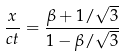Convert formula to latex. <formula><loc_0><loc_0><loc_500><loc_500>\frac { x } { c t } = \frac { \beta + 1 / \sqrt { 3 } } { 1 - \beta / \sqrt { 3 } }</formula> 